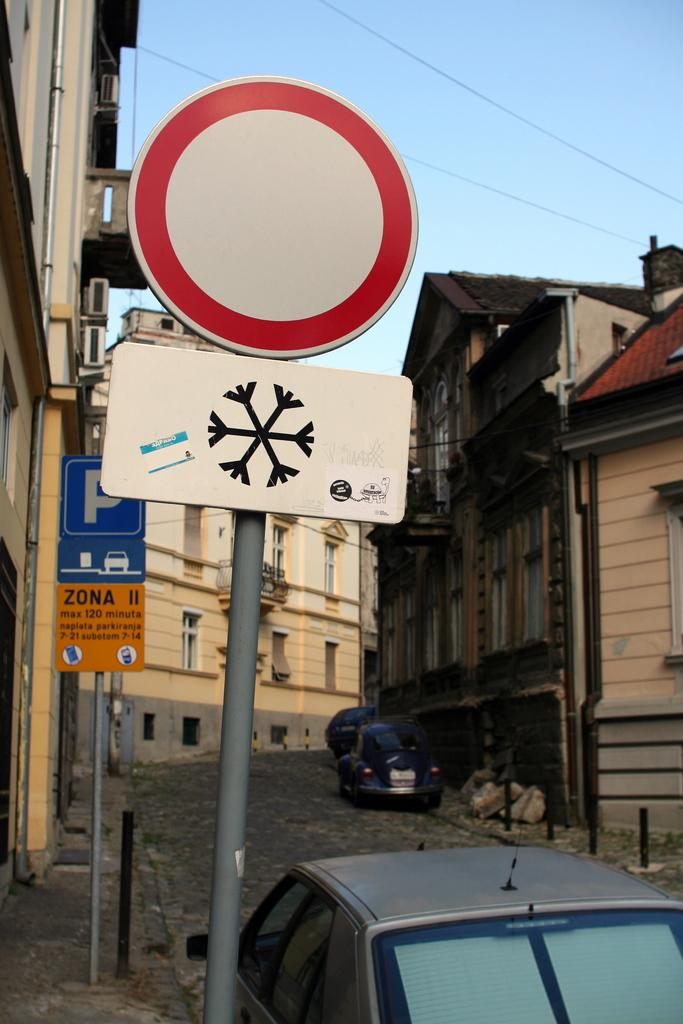What is attached to the poles in the image? There are boards attached to poles in the image. What can be seen on the road in the image? There are vehicles on the road in the image. What type of structures are present in the image? There are buildings in the image. What appliances are visible in the image? Air conditioners are visible in the image. What is visible in the background of the image? The sky is visible in the background of the image. Are there any dinosaurs present in the image? No, there are no dinosaurs present in the image. What nation is depicted in the image? The image does not depict a specific nation; it shows a scene with boards, vehicles, buildings, air conditioners, and the sky. 